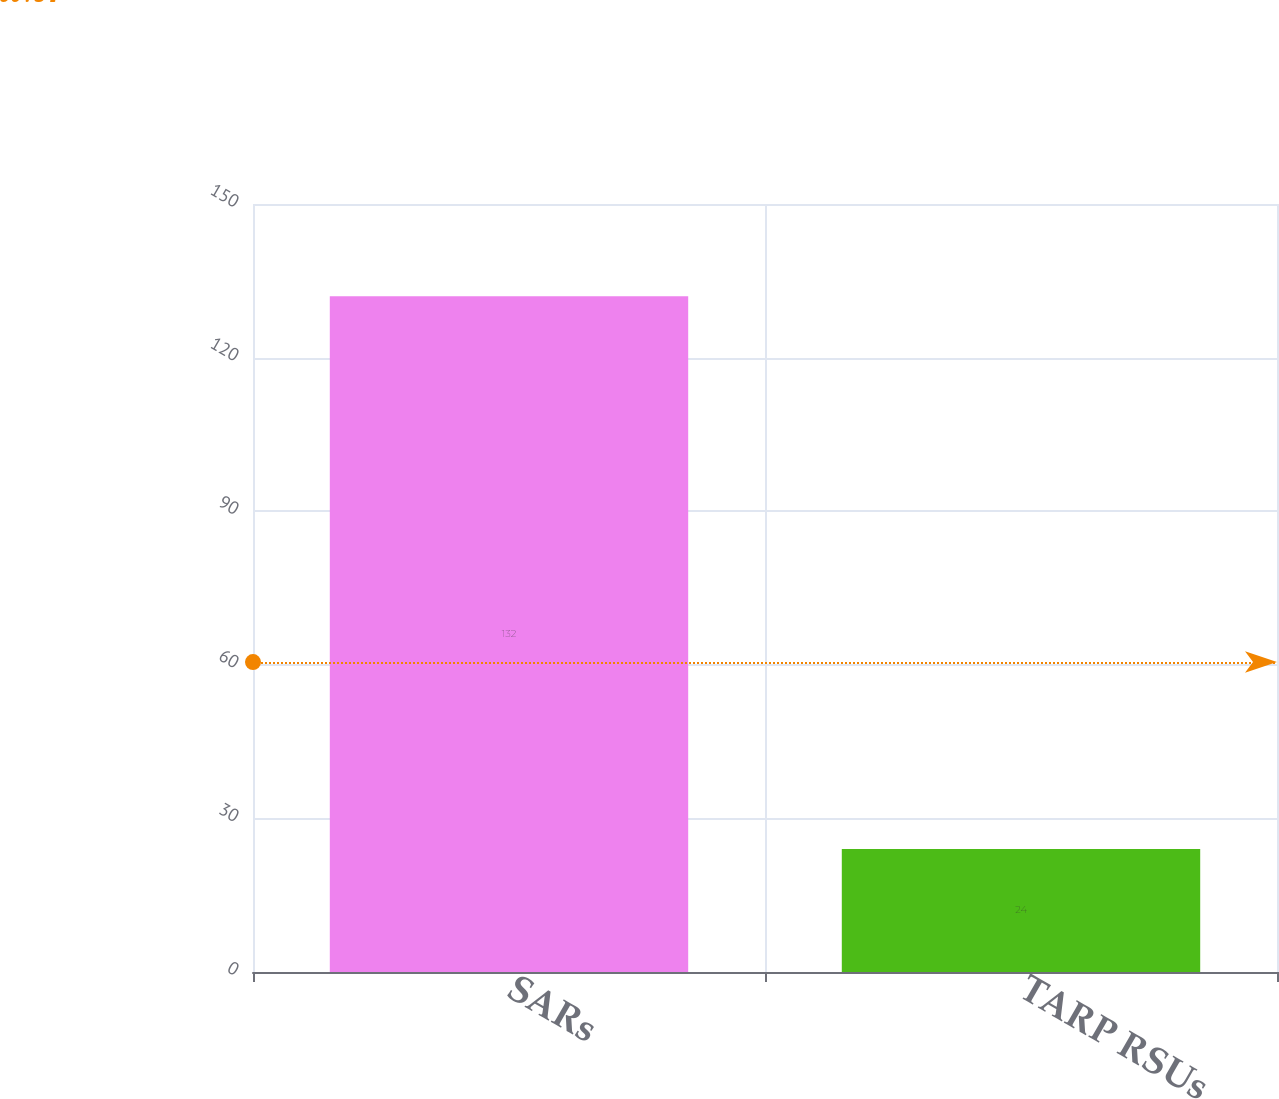<chart> <loc_0><loc_0><loc_500><loc_500><bar_chart><fcel>SARs<fcel>TARP RSUs<nl><fcel>132<fcel>24<nl></chart> 